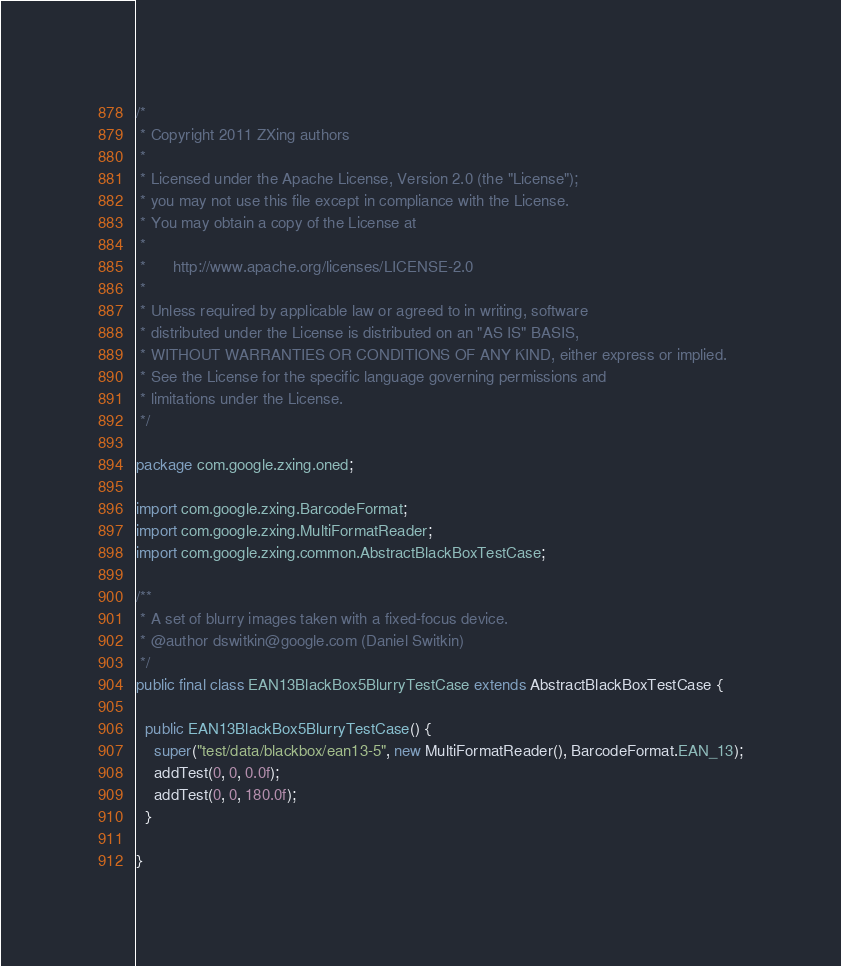<code> <loc_0><loc_0><loc_500><loc_500><_Java_>/*
 * Copyright 2011 ZXing authors
 *
 * Licensed under the Apache License, Version 2.0 (the "License");
 * you may not use this file except in compliance with the License.
 * You may obtain a copy of the License at
 *
 *      http://www.apache.org/licenses/LICENSE-2.0
 *
 * Unless required by applicable law or agreed to in writing, software
 * distributed under the License is distributed on an "AS IS" BASIS,
 * WITHOUT WARRANTIES OR CONDITIONS OF ANY KIND, either express or implied.
 * See the License for the specific language governing permissions and
 * limitations under the License.
 */

package com.google.zxing.oned;

import com.google.zxing.BarcodeFormat;
import com.google.zxing.MultiFormatReader;
import com.google.zxing.common.AbstractBlackBoxTestCase;

/**
 * A set of blurry images taken with a fixed-focus device.
 * @author dswitkin@google.com (Daniel Switkin)
 */
public final class EAN13BlackBox5BlurryTestCase extends AbstractBlackBoxTestCase {

  public EAN13BlackBox5BlurryTestCase() {
    super("test/data/blackbox/ean13-5", new MultiFormatReader(), BarcodeFormat.EAN_13);
    addTest(0, 0, 0.0f);
    addTest(0, 0, 180.0f);
  }

}
</code> 